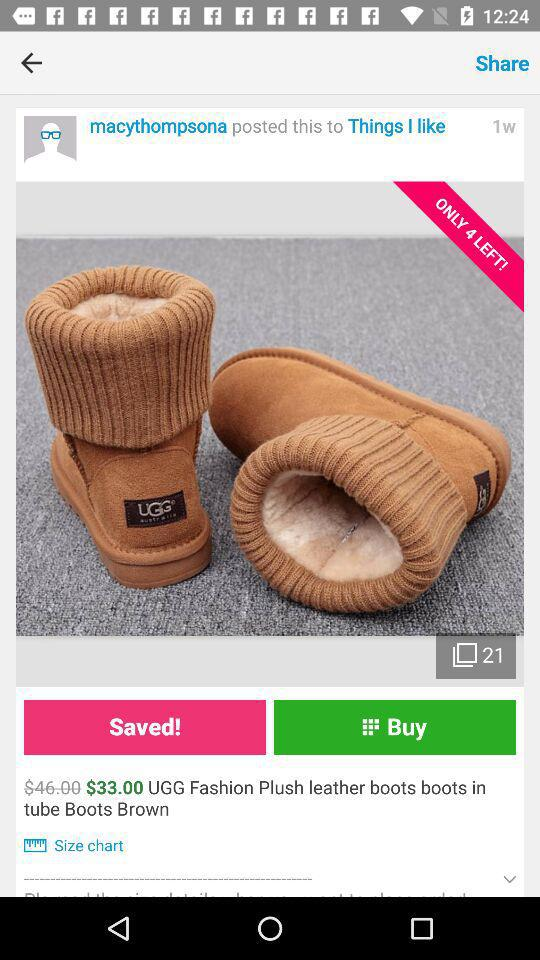Who posted the picture? The picture was posted by macythompsona. 